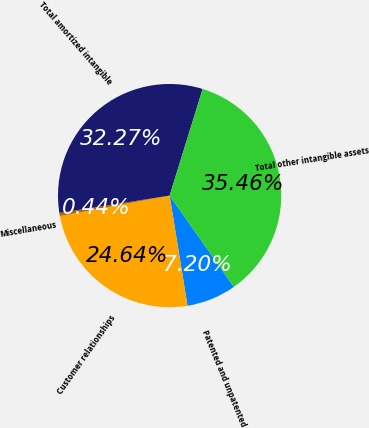<chart> <loc_0><loc_0><loc_500><loc_500><pie_chart><fcel>Patented and unpatented<fcel>Customer relationships<fcel>Miscellaneous<fcel>Total amortized intangible<fcel>Total other intangible assets<nl><fcel>7.2%<fcel>24.64%<fcel>0.44%<fcel>32.27%<fcel>35.46%<nl></chart> 